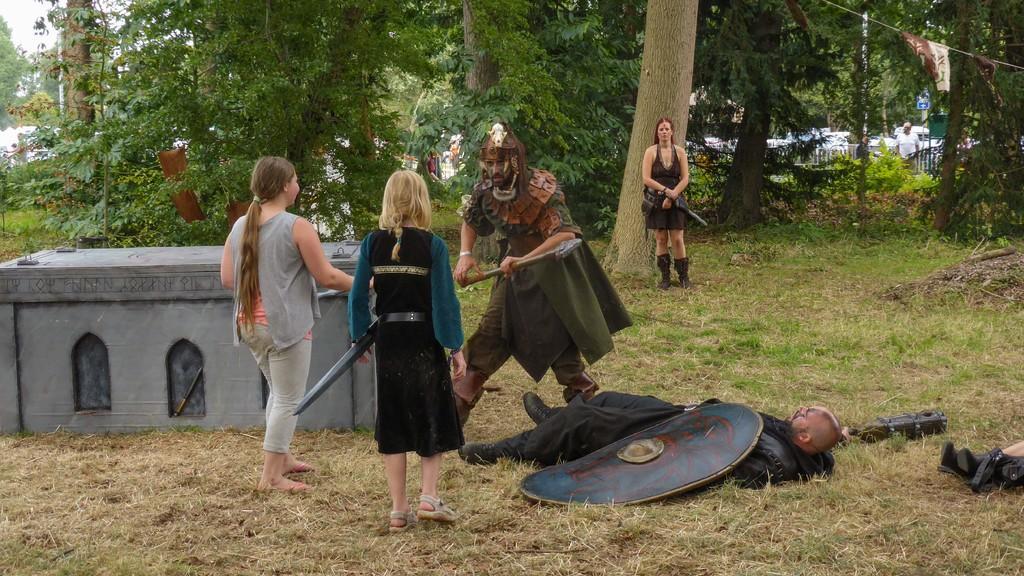Can you describe this image briefly? In the middle of this image, there is a person standing and holding an object. Beside him, there is a person in black color dress lying on the ground. For this person, there is a shield. Beside this person, there are two women standing. Beside them, there is a model building. In the background, there is a woman standing on the ground. Beside her, there is a tree. There are trees, a person, plants and grass on the ground. 